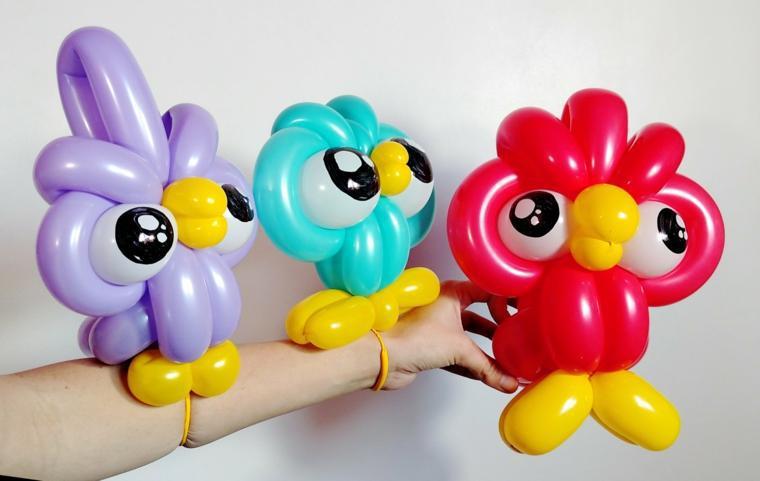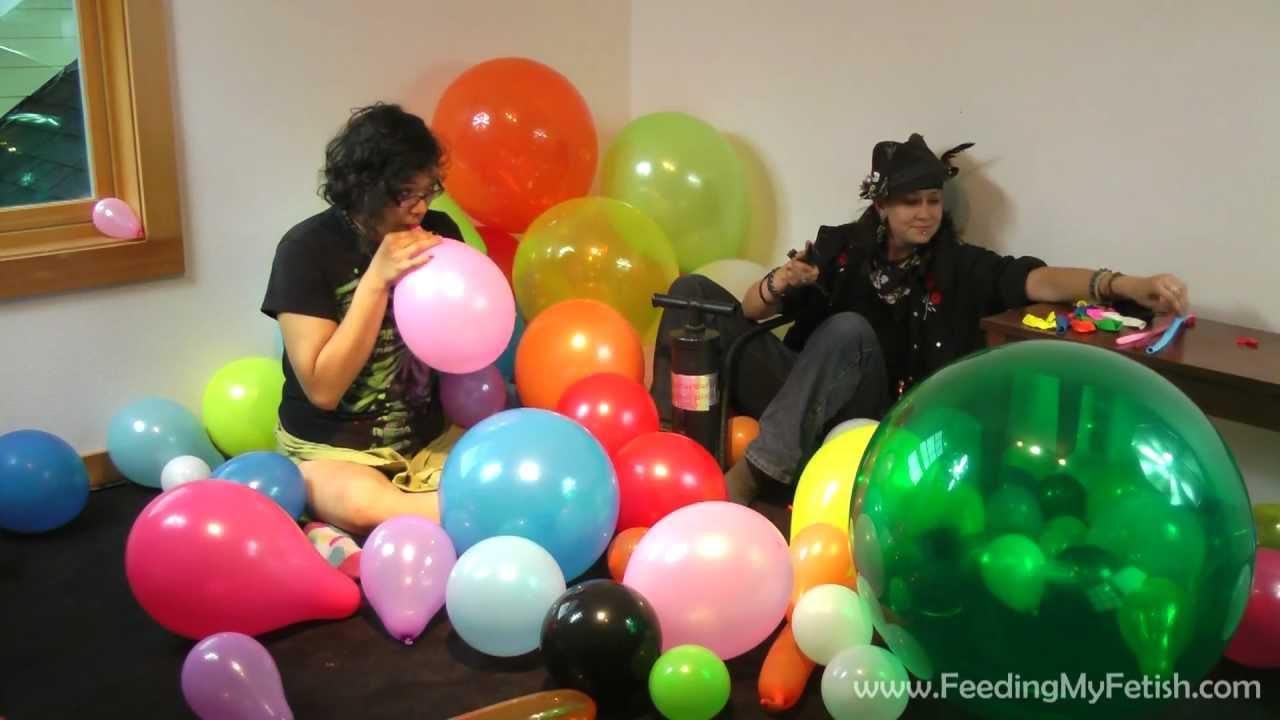The first image is the image on the left, the second image is the image on the right. Given the left and right images, does the statement "There are exactly three colorful objects in the left image." hold true? Answer yes or no. Yes. The first image is the image on the left, the second image is the image on the right. Analyze the images presented: Is the assertion "The right image features a balloon garland hung at the top of a wall and containing at least a dozen balloons." valid? Answer yes or no. No. 